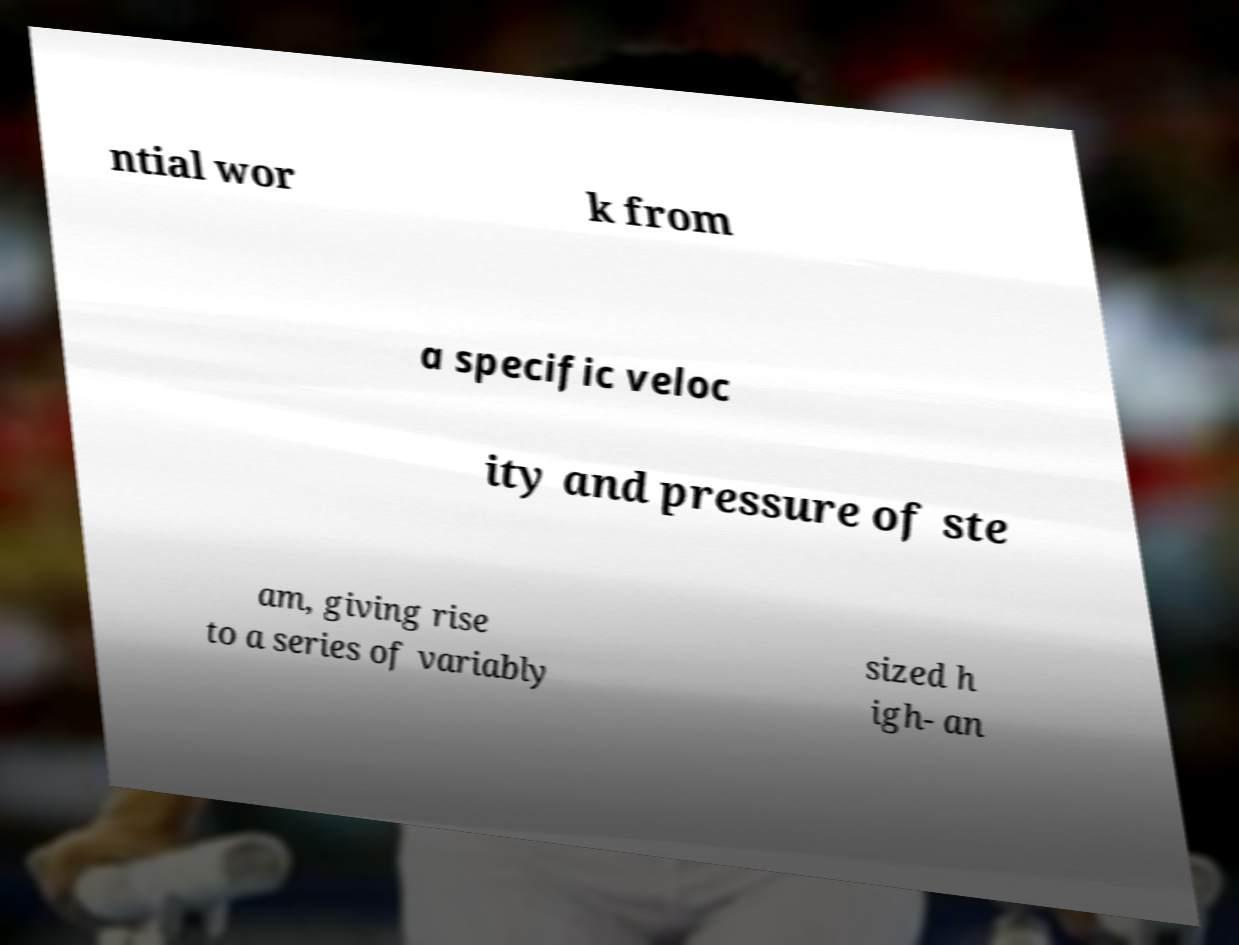Can you read and provide the text displayed in the image?This photo seems to have some interesting text. Can you extract and type it out for me? ntial wor k from a specific veloc ity and pressure of ste am, giving rise to a series of variably sized h igh- an 